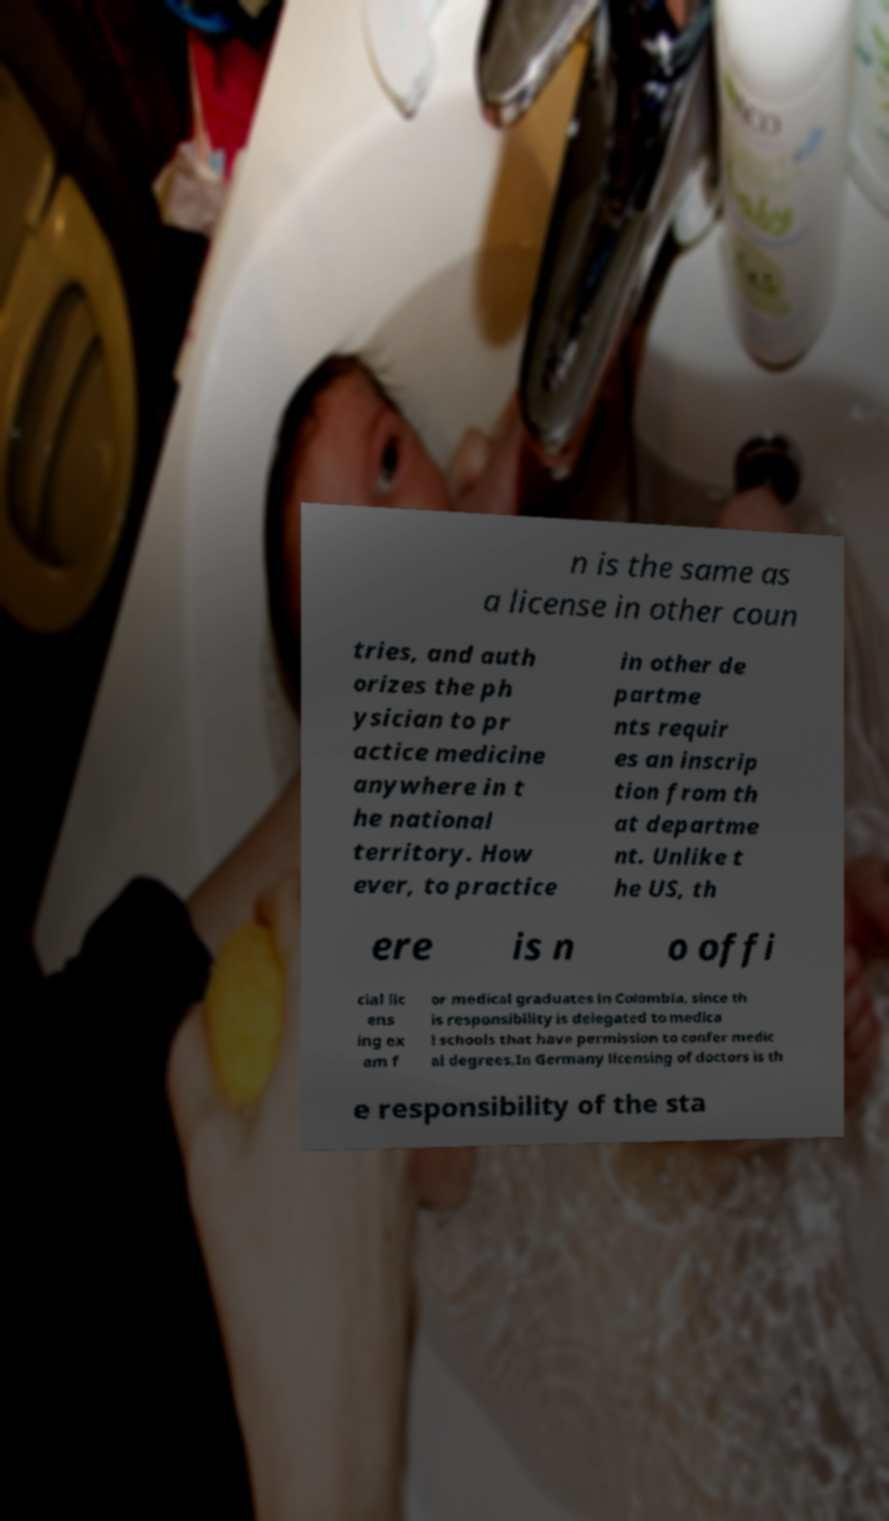Please identify and transcribe the text found in this image. n is the same as a license in other coun tries, and auth orizes the ph ysician to pr actice medicine anywhere in t he national territory. How ever, to practice in other de partme nts requir es an inscrip tion from th at departme nt. Unlike t he US, th ere is n o offi cial lic ens ing ex am f or medical graduates in Colombia, since th is responsibility is delegated to medica l schools that have permission to confer medic al degrees.In Germany licensing of doctors is th e responsibility of the sta 